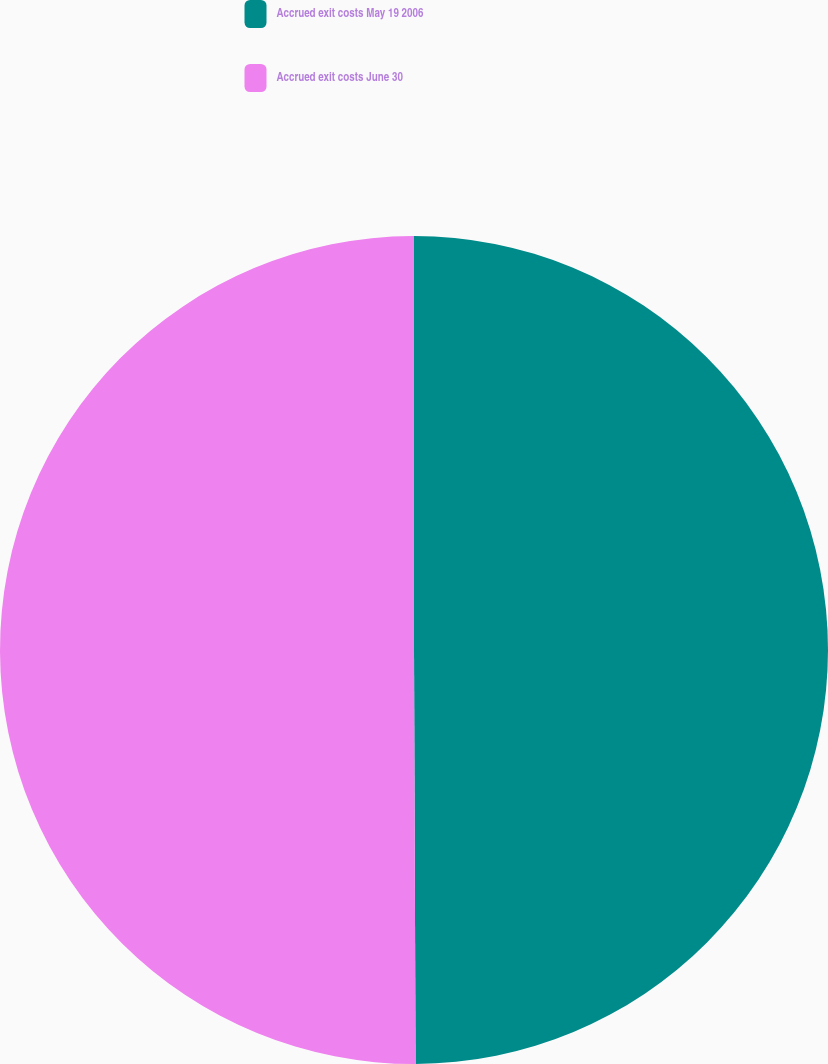Convert chart to OTSL. <chart><loc_0><loc_0><loc_500><loc_500><pie_chart><fcel>Accrued exit costs May 19 2006<fcel>Accrued exit costs June 30<nl><fcel>49.94%<fcel>50.06%<nl></chart> 